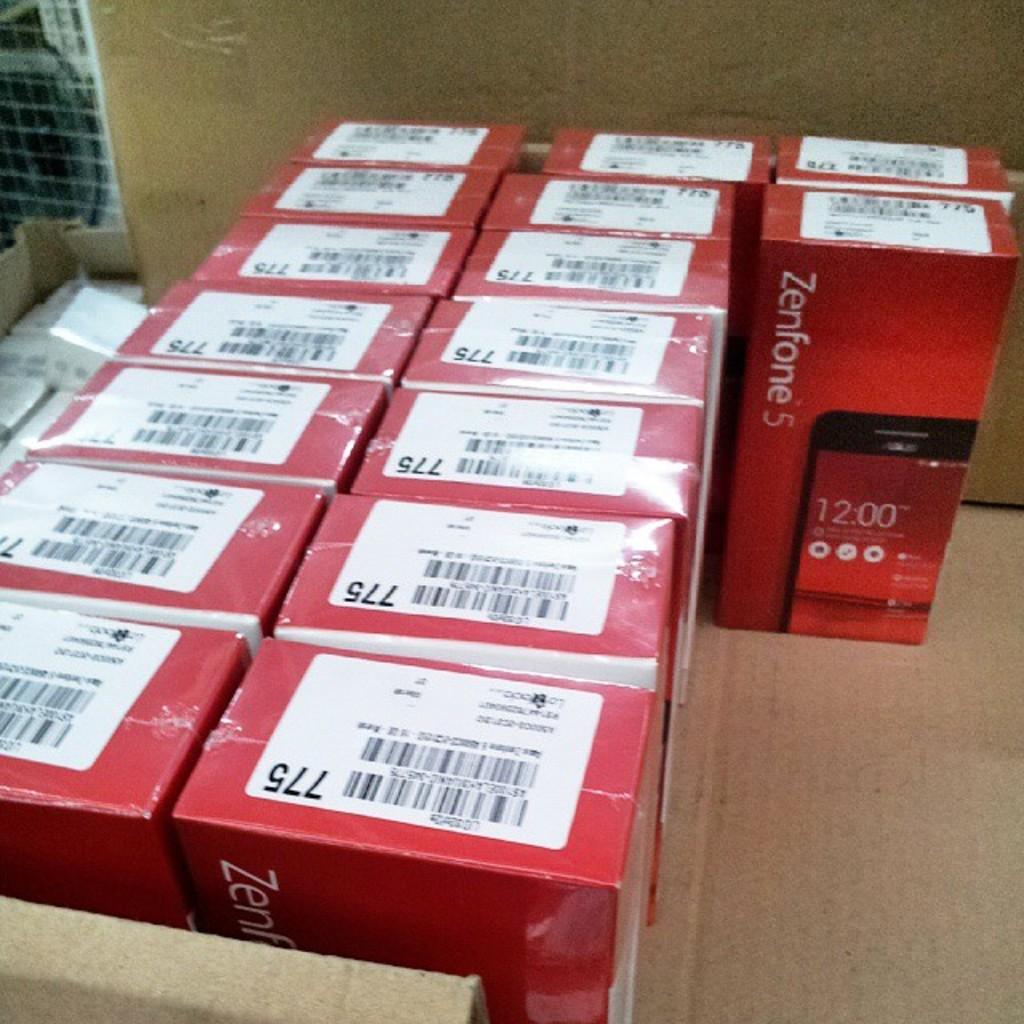What kind of phones are in the boxes?
Ensure brevity in your answer.  Zenfone 5. Whats the number on theboxes?
Offer a terse response. 775. 